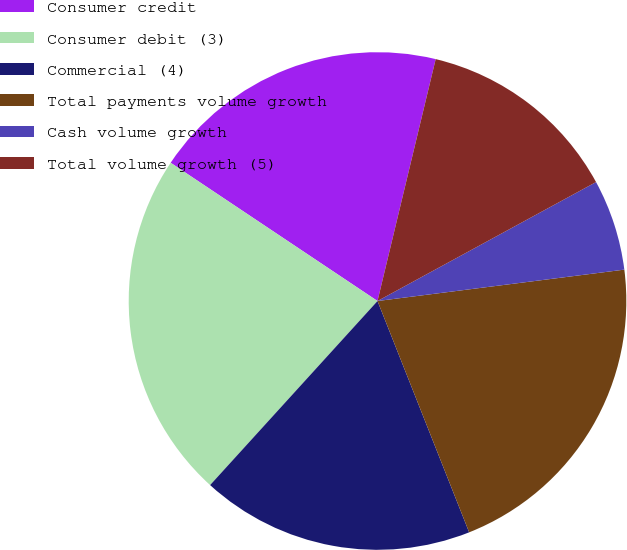Convert chart to OTSL. <chart><loc_0><loc_0><loc_500><loc_500><pie_chart><fcel>Consumer credit<fcel>Consumer debit (3)<fcel>Commercial (4)<fcel>Total payments volume growth<fcel>Cash volume growth<fcel>Total volume growth (5)<nl><fcel>19.38%<fcel>22.63%<fcel>17.75%<fcel>21.01%<fcel>5.92%<fcel>13.31%<nl></chart> 